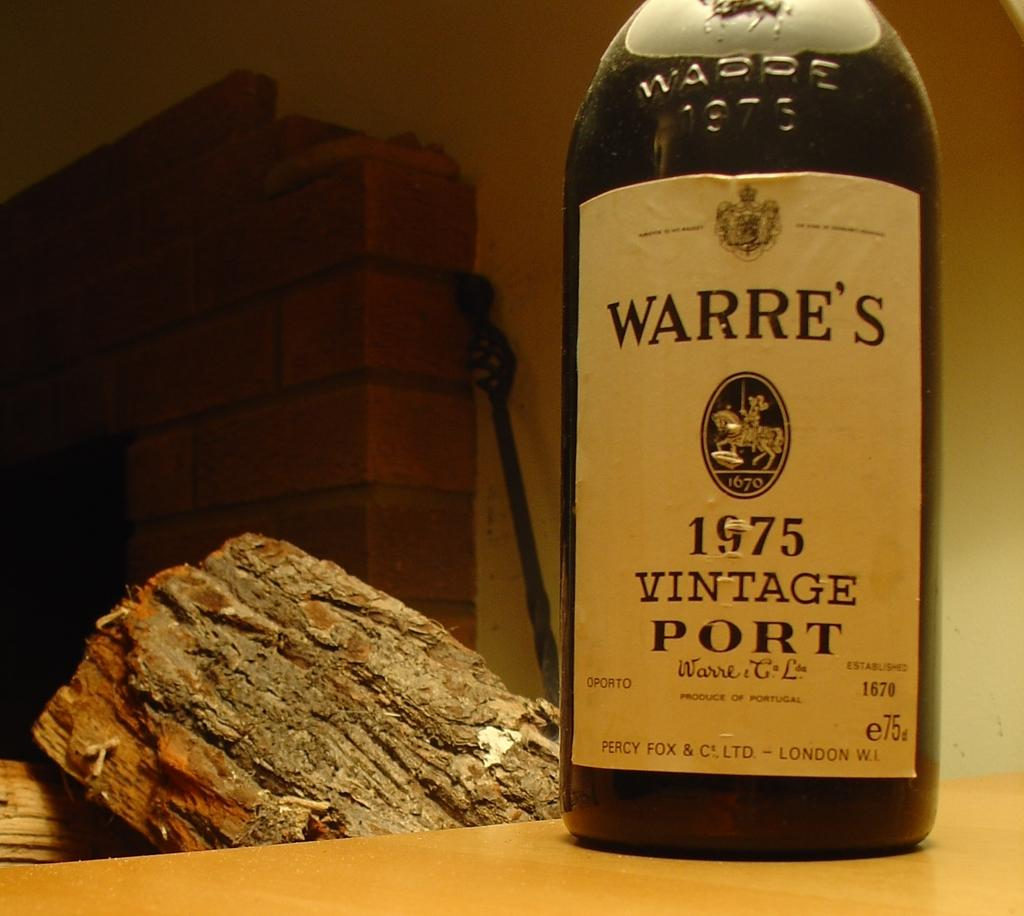<image>
Create a compact narrative representing the image presented. A bottle of Warre's from 1975, vintage port. 